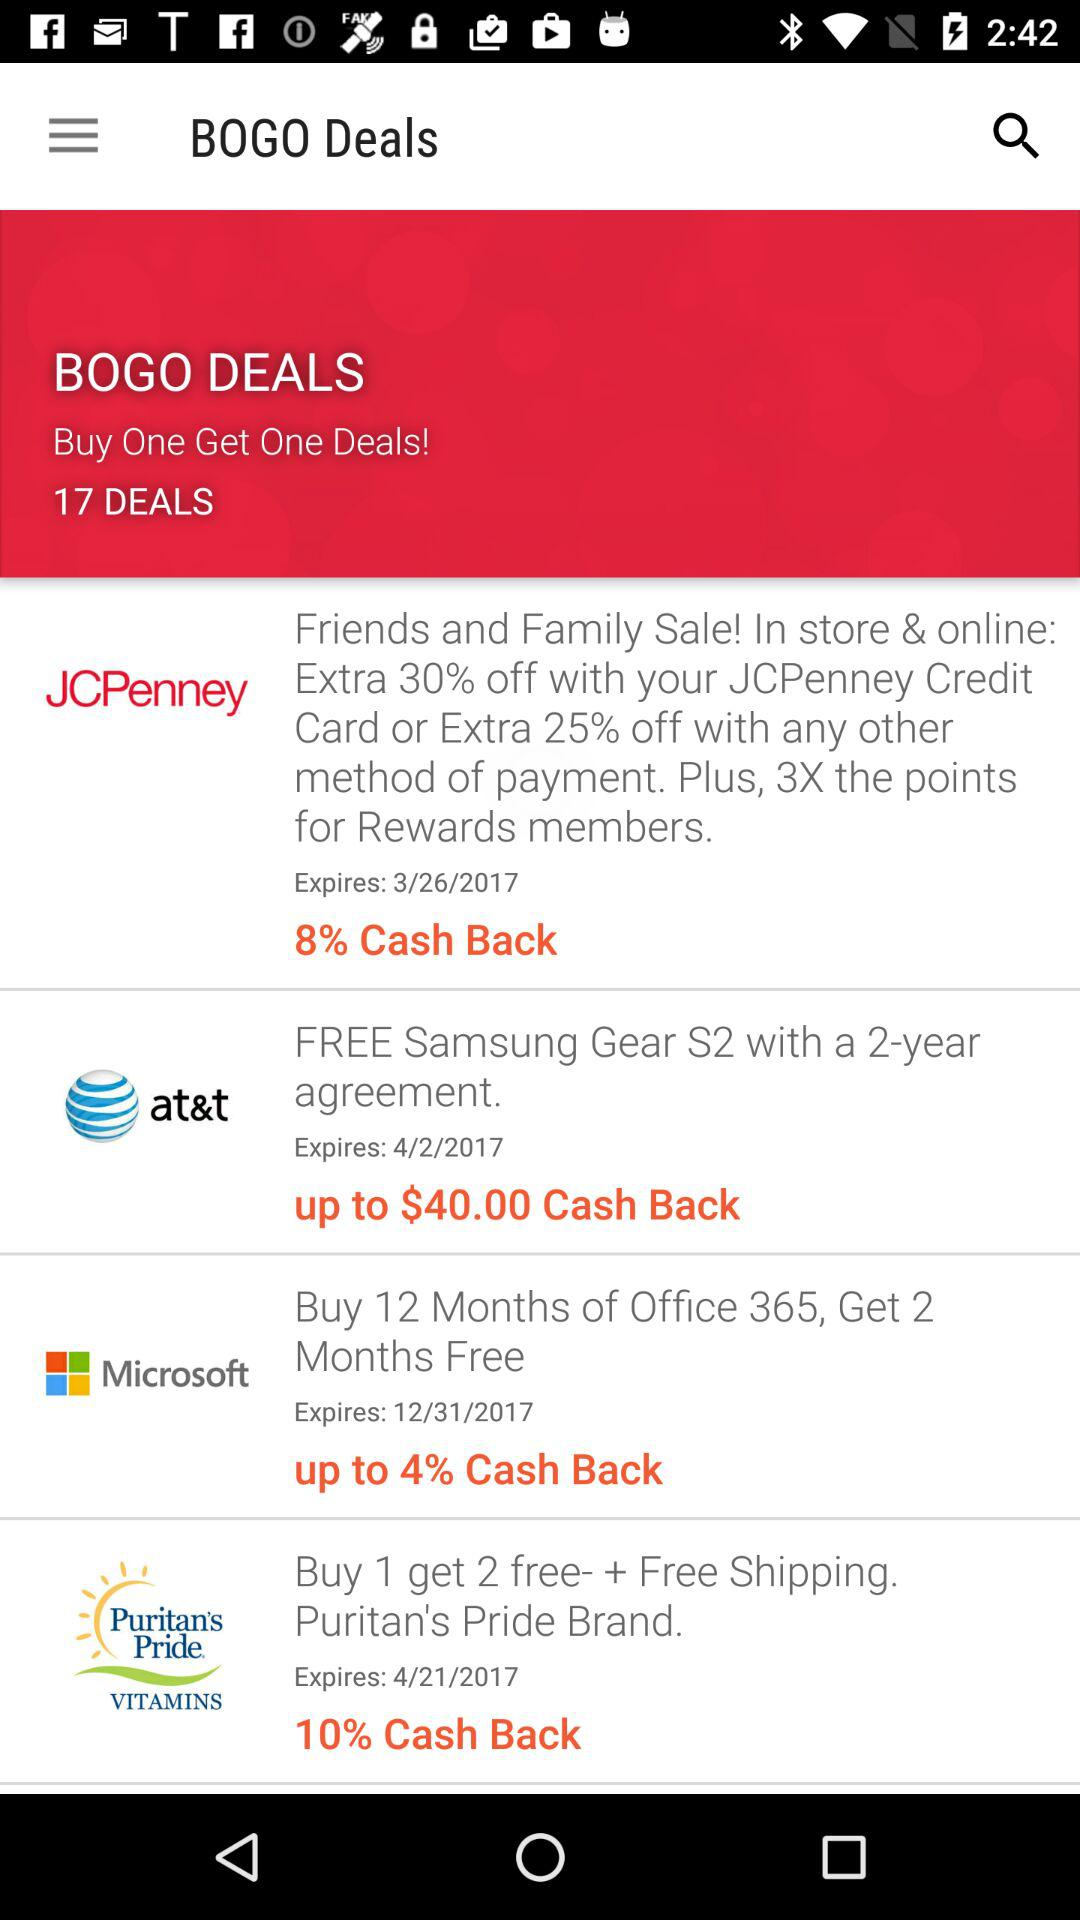Are these cash back offers tied to specific payment methods? Yes, some of the offers, such as the JCPenney deal, specify that additional discounts are available with certain payment methods, like the JCPenney Credit Card. How long do I have to take advantage of the JCPenney deal? The JCPenney deal shown in the image expires on 3/26/2017, so the offer must be taken advantage of before or on that date. 